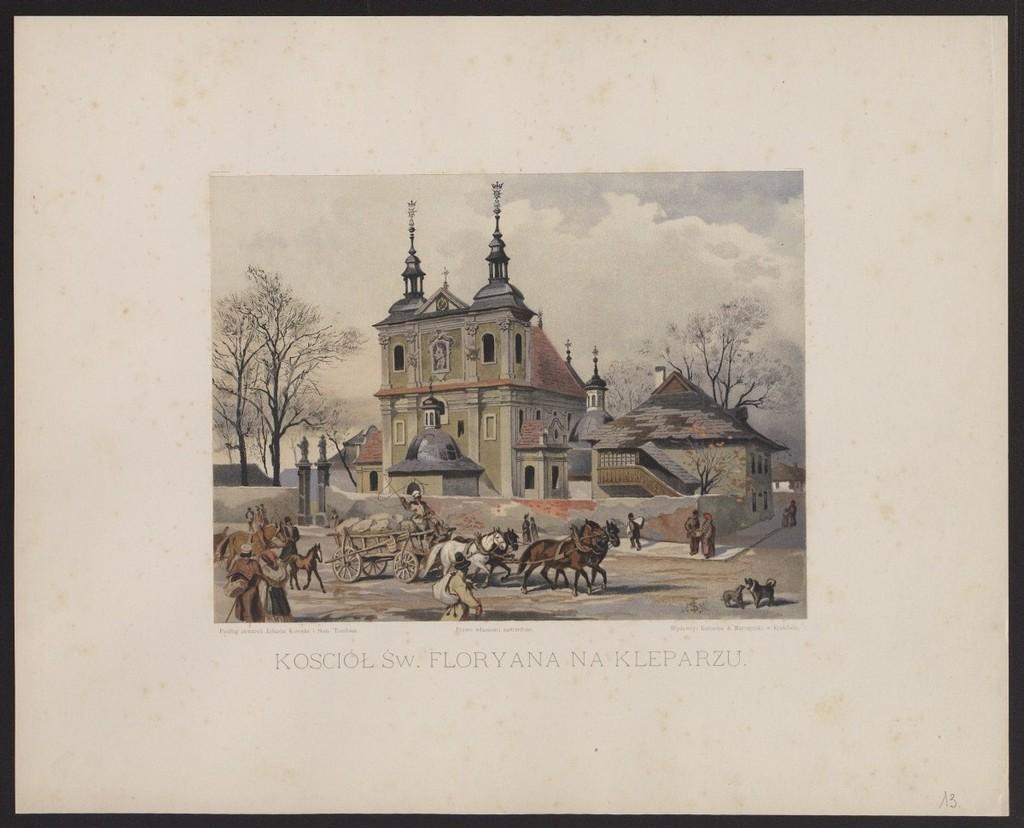How would you summarize this image in a sentence or two? In the center of the image we can see a poster. On the poster, we can see the sky, clouds, trees, buildings, few people, animals and a few other objects. And we can see some text on the poster. And we can see the black colored border around the image. 